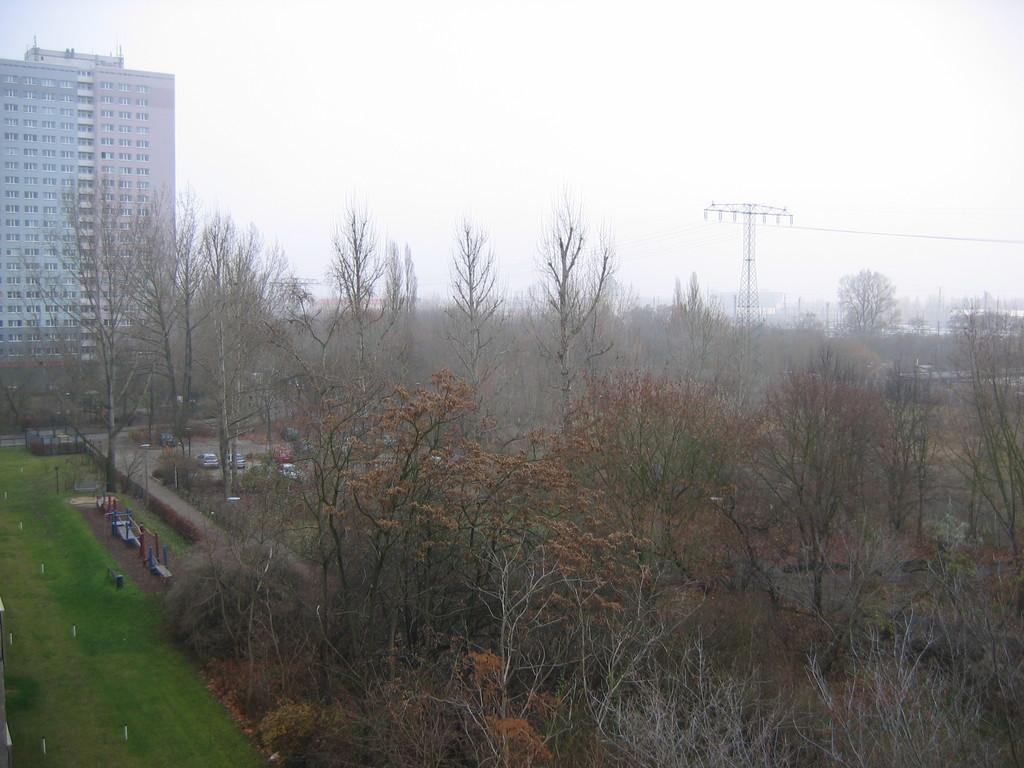What type of vegetation can be seen in the image? There are dried trees in the image. What is the color of the grass in the image? The grass is green in the image. What structures can be seen in the background of the image? There is a tower and a building in the background of the image. What is the color of the sky in the image? The sky is white in the image. How does the pear compare to the trees in the image? There is no pear present in the image, so it cannot be compared to the trees. What time is displayed on the watch in the image? There is no watch present in the image, so the time cannot be determined. 